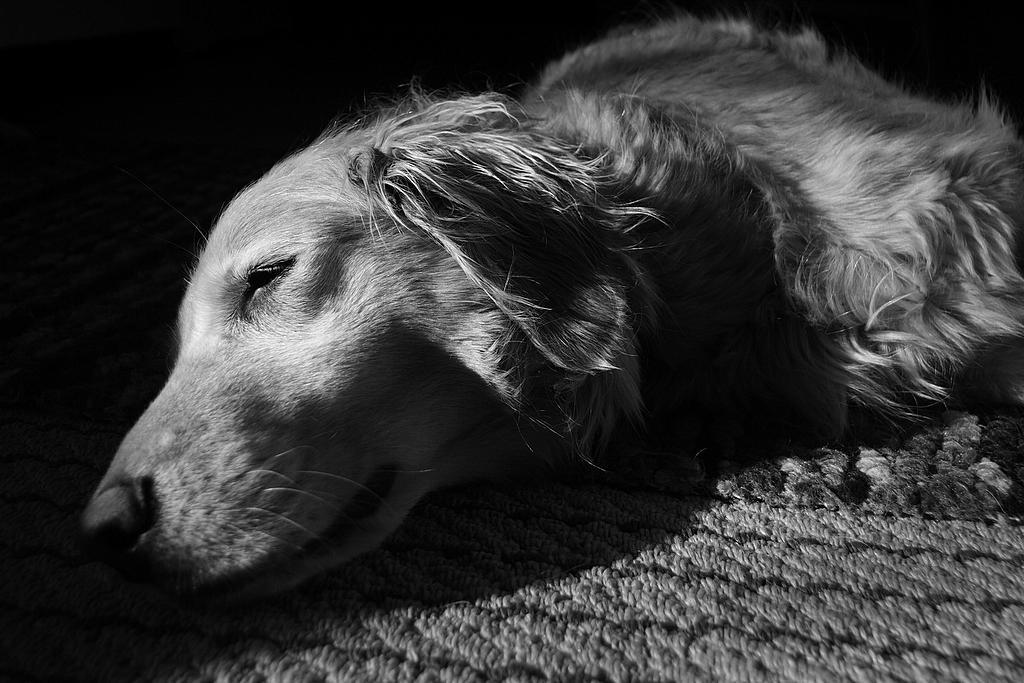Describe this image in one or two sentences. In this image we can see a dog sleeping on the mat. 